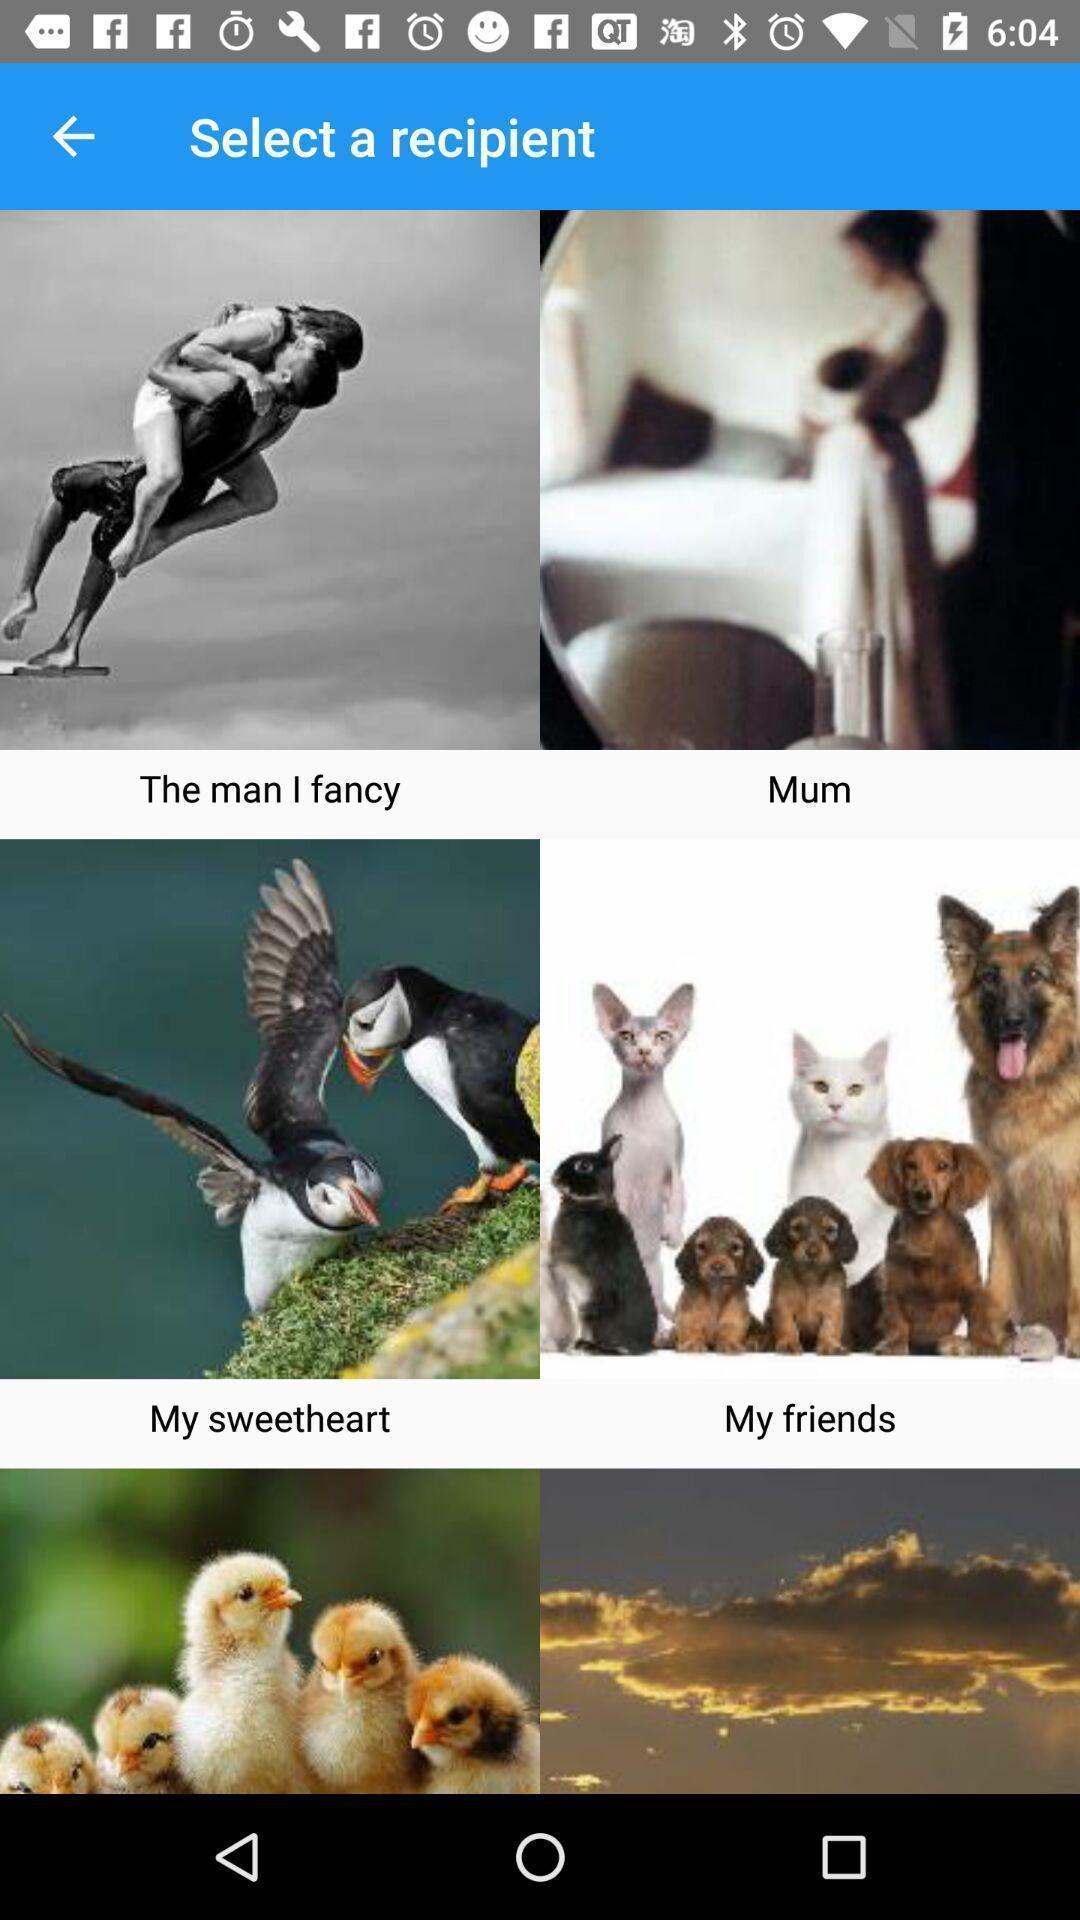Summarize the information in this screenshot. Page for selecting a recipient of stickers and emojis app. 